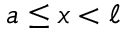Convert formula to latex. <formula><loc_0><loc_0><loc_500><loc_500>a \leq x < \ell</formula> 